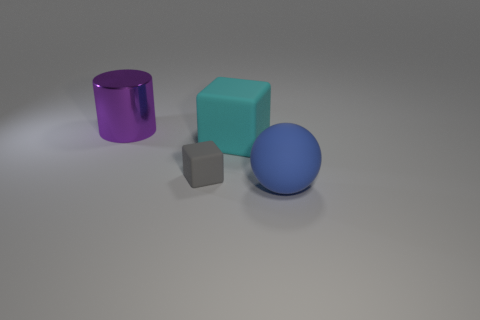Add 3 gray matte blocks. How many objects exist? 7 Subtract all balls. How many objects are left? 3 Add 4 gray things. How many gray things exist? 5 Subtract 0 purple cubes. How many objects are left? 4 Subtract all tiny rubber cubes. Subtract all large cyan matte things. How many objects are left? 2 Add 1 small things. How many small things are left? 2 